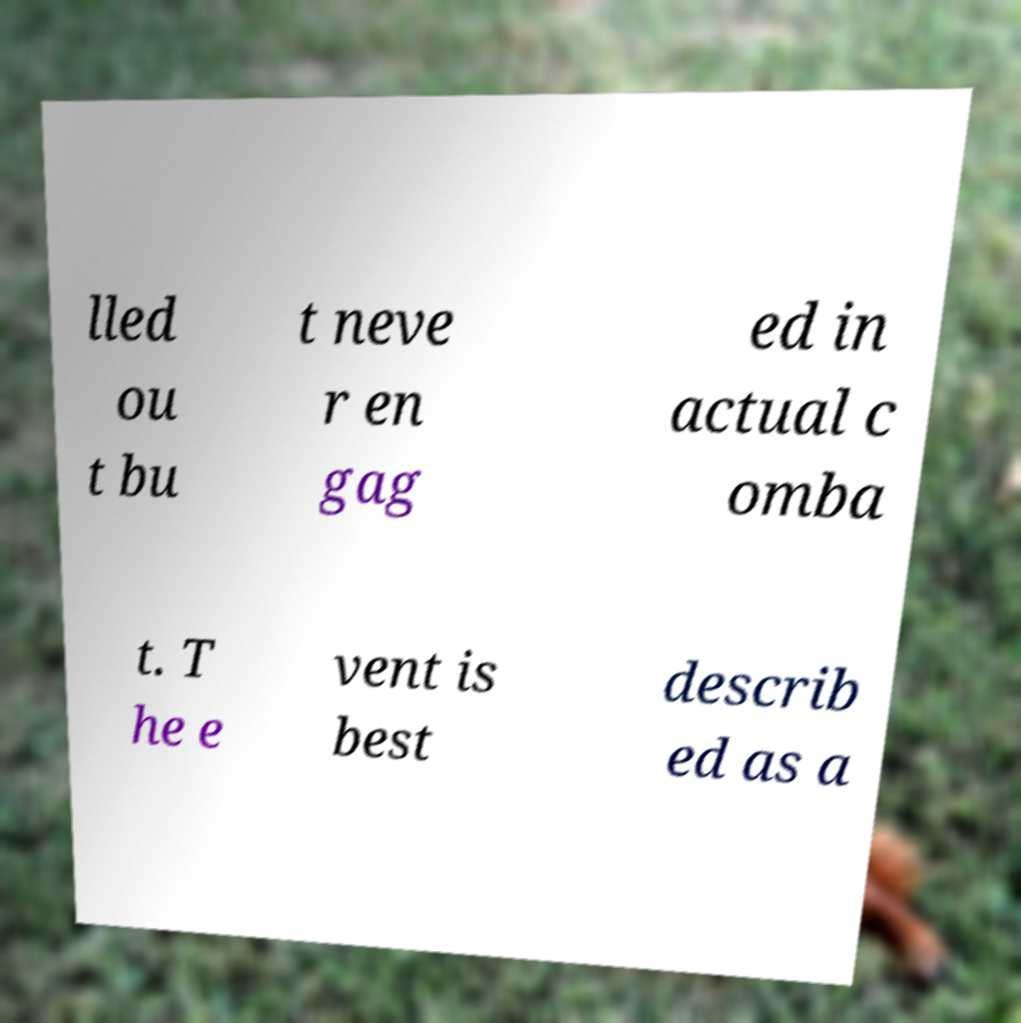Can you read and provide the text displayed in the image?This photo seems to have some interesting text. Can you extract and type it out for me? lled ou t bu t neve r en gag ed in actual c omba t. T he e vent is best describ ed as a 